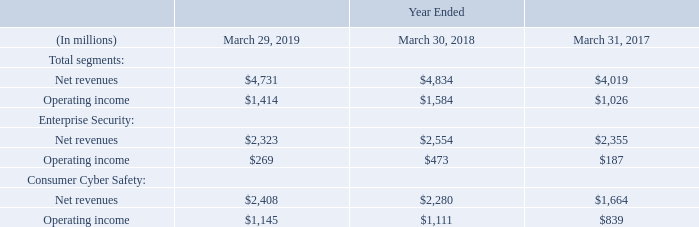We operate in the following two reportable segments, which are the same as our operating segments:
• Enterprise Security. Our Enterprise Security segment focuses on providing our Integrated Cyber Defense solutions to help business and government customers unify cloud and on-premises security to deliver a more effective cyber defense solution, while driving down cost and complexity. • Consumer Cyber Safety. Our Consumer Cyber Safety segment focuses on providing cyber safety solutions under our Norton LifeLock brand to help consumers protect their devices, online privacy, identities, and home networks.
Operating segments are based upon the nature of our business and how our business is managed. Our Chief Operating Decision Makers, comprised of our Chief Executive Officer and Chief Financial Officer, use our operating segment financial information to evaluate segment performance and to allocate resources.
There were no inter-segment sales for the periods presented. The following table summarizes the operating results of our reportable segments:
Note 15. Segment and Geographic Information
What are the two reportable segments? Enterprise security, consumer cyber safety. What does the table represent? Summarizes the operating results of our reportable segments. What is the total segments operating income for Year ended  March 29, 2019?
Answer scale should be: million. $1,414. What is the average total segments Operating income for the fiscal years 2019, 2018 and 2017?
Answer scale should be: million. (1,414+1,584+1,026)/3
Answer: 1341.33. What is the average total segments Net revenues for the fiscal years 2019, 2018 and 2017?
Answer scale should be: million. (4,731+4,834+4,019)/3
Answer: 4528. For fiscal year 2019, what is the total segements Operating income expressed as a percentage of net revenues?
Answer scale should be: percent. 1,414/4,731
Answer: 29.89. 